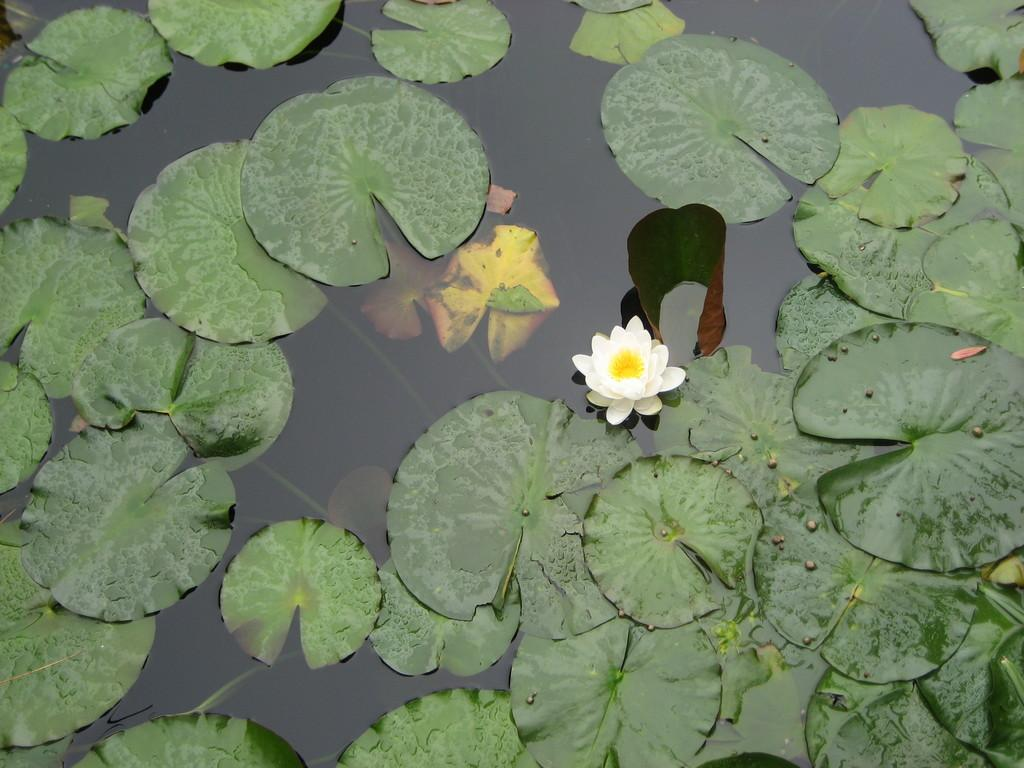What is located in the middle of the pond in the image? There is a flower in the middle of the pond. What else can be seen floating in the water? Leaves are floating in the water. What type of animal can be seen drinking from the pail in the image? There is no pail or animal present in the image. What design is featured on the flower in the image? The image does not provide enough detail to describe the design of the flower. 